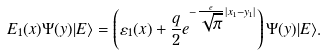Convert formula to latex. <formula><loc_0><loc_0><loc_500><loc_500>E _ { 1 } ( x ) \Psi ( y ) | E \rangle = \left ( { \varepsilon _ { 1 } ( x ) + \frac { q } { 2 } e ^ { - \frac { e } { \sqrt { \pi } } | x _ { 1 } - y _ { 1 } | } } \right ) \Psi ( y ) | E \rangle .</formula> 